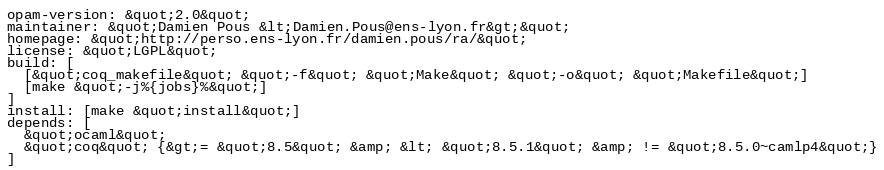<code> <loc_0><loc_0><loc_500><loc_500><_HTML_>opam-version: &quot;2.0&quot;
maintainer: &quot;Damien Pous &lt;Damien.Pous@ens-lyon.fr&gt;&quot;
homepage: &quot;http://perso.ens-lyon.fr/damien.pous/ra/&quot;
license: &quot;LGPL&quot;
build: [
  [&quot;coq_makefile&quot; &quot;-f&quot; &quot;Make&quot; &quot;-o&quot; &quot;Makefile&quot;]
  [make &quot;-j%{jobs}%&quot;]
]
install: [make &quot;install&quot;]
depends: [
  &quot;ocaml&quot;
  &quot;coq&quot; {&gt;= &quot;8.5&quot; &amp; &lt; &quot;8.5.1&quot; &amp; != &quot;8.5.0~camlp4&quot;}
]</code> 